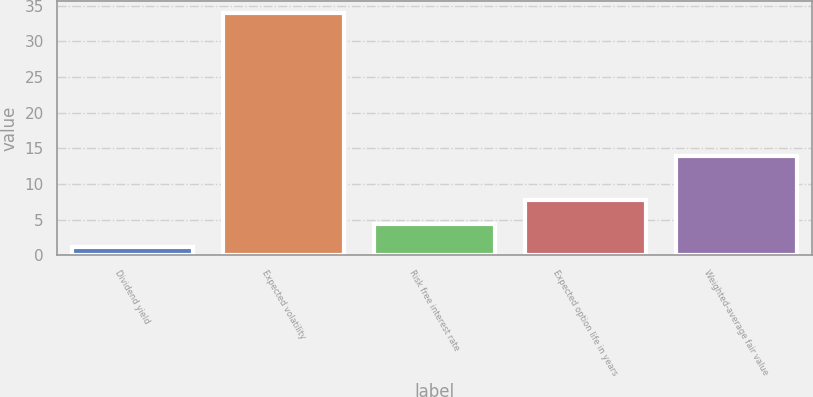Convert chart to OTSL. <chart><loc_0><loc_0><loc_500><loc_500><bar_chart><fcel>Dividend yield<fcel>Expected volatility<fcel>Risk free interest rate<fcel>Expected option life in years<fcel>Weighted-average fair value<nl><fcel>1.2<fcel>34<fcel>4.48<fcel>7.76<fcel>13.92<nl></chart> 